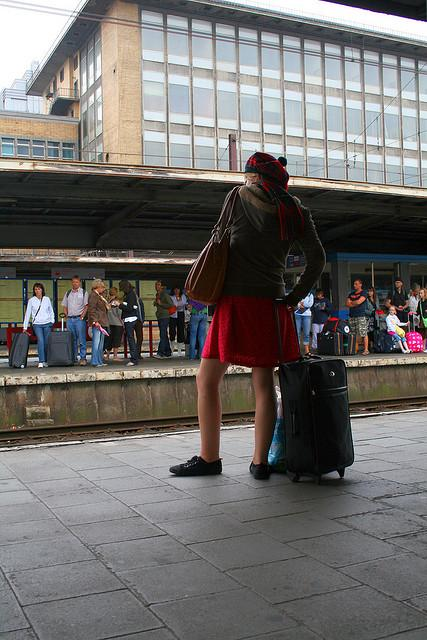What color is the suitcase held by the girl on the other side of the boarding deck to the right of the woman in the foreground? Please explain your reasoning. pink. It stands out on the screen as it is a very bright colour, which can be identified as pink. 